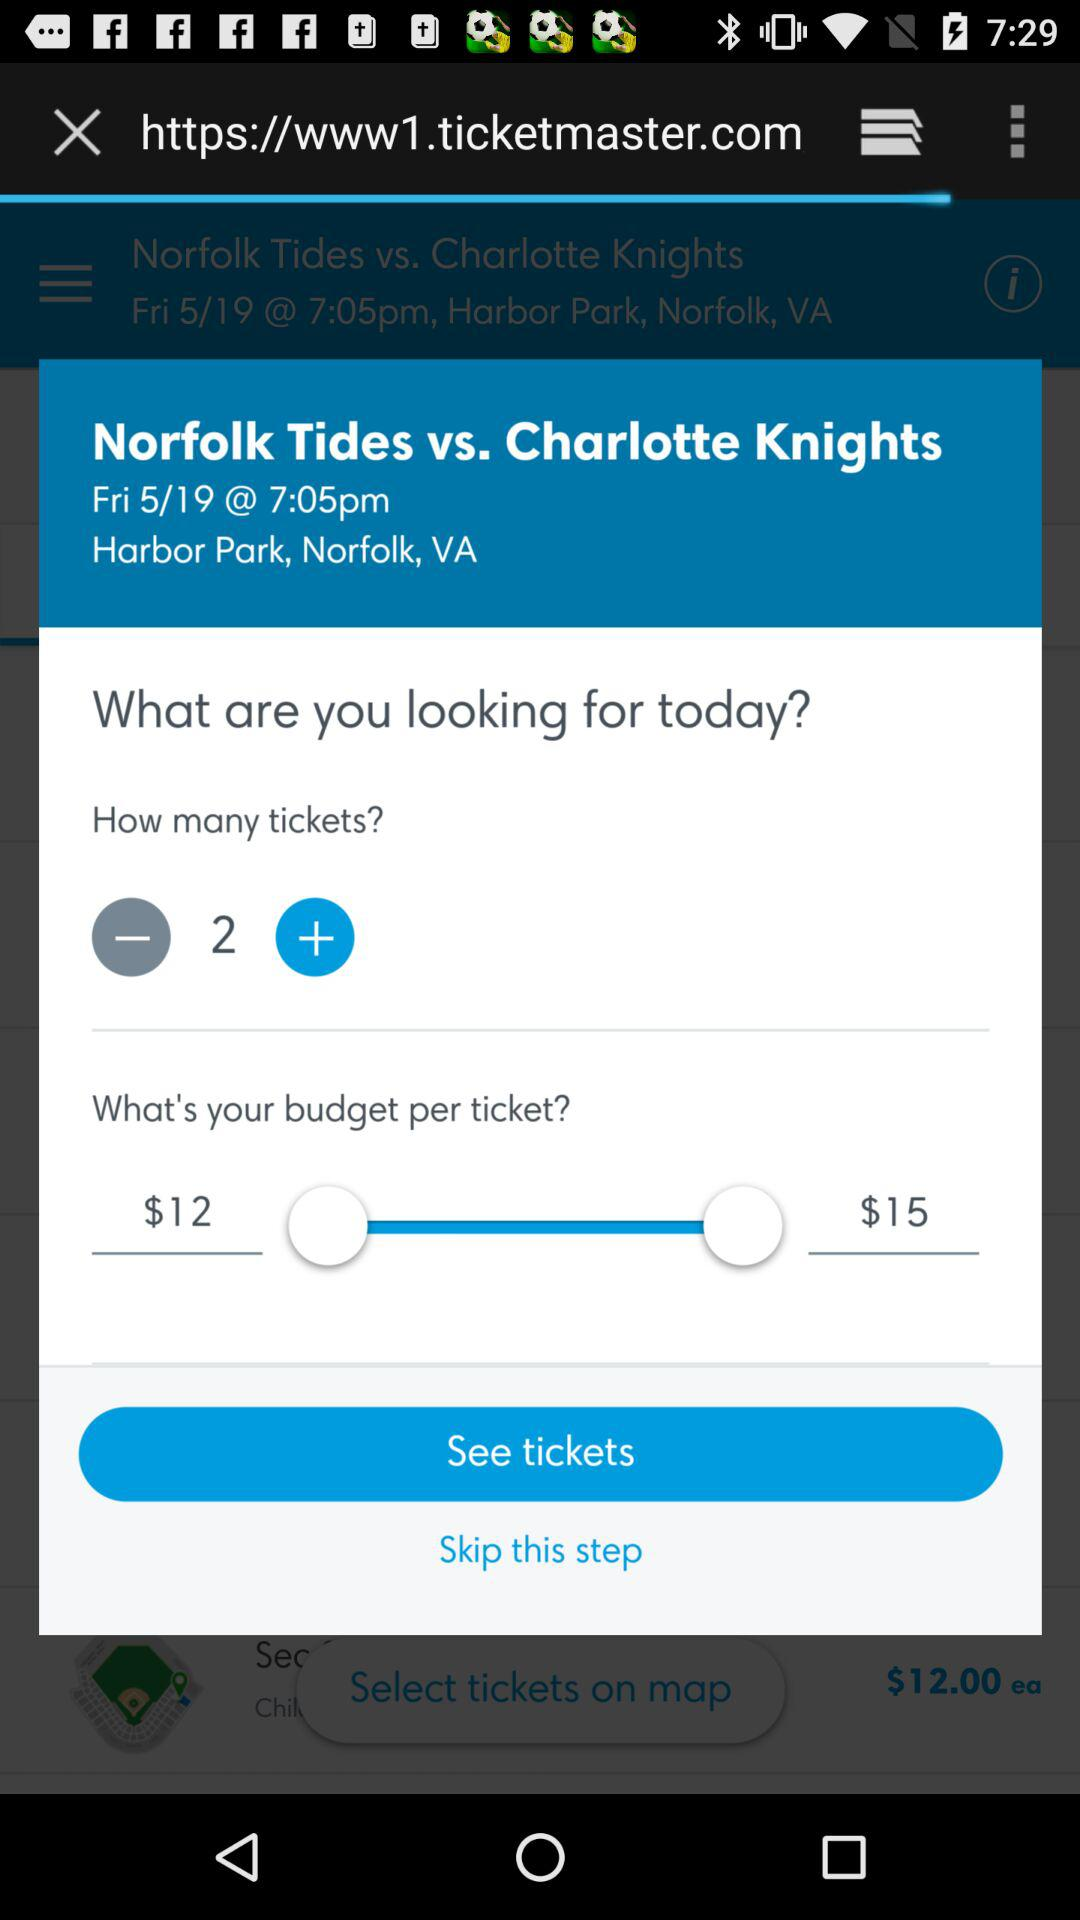What is the difference in price between the two budget options?
Answer the question using a single word or phrase. $3 